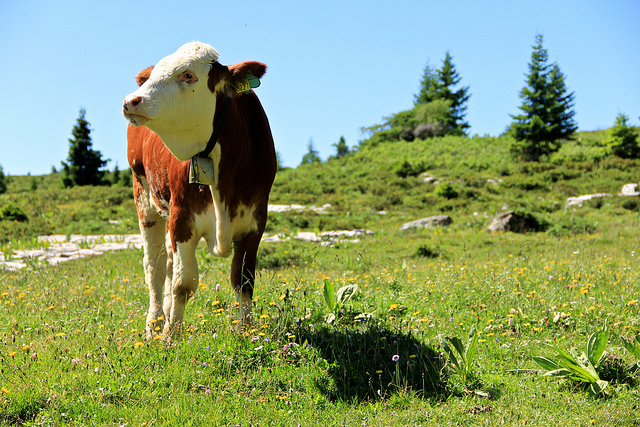<image>What is the cows name? I don't know what the cow's name is. It could be 'bo', 'betsy', 'bess' or 'elsie'. What is the cows name? I don't know the name of the cow. It can be 'bo', 'betsy', 'bess', 'elsie', 'best', or 'bessie'. 